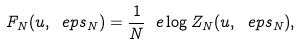<formula> <loc_0><loc_0><loc_500><loc_500>F _ { N } ( u , \ e p s _ { N } ) = \frac { 1 } { N } \ e \log Z _ { N } ( u , \ e p s _ { N } ) ,</formula> 